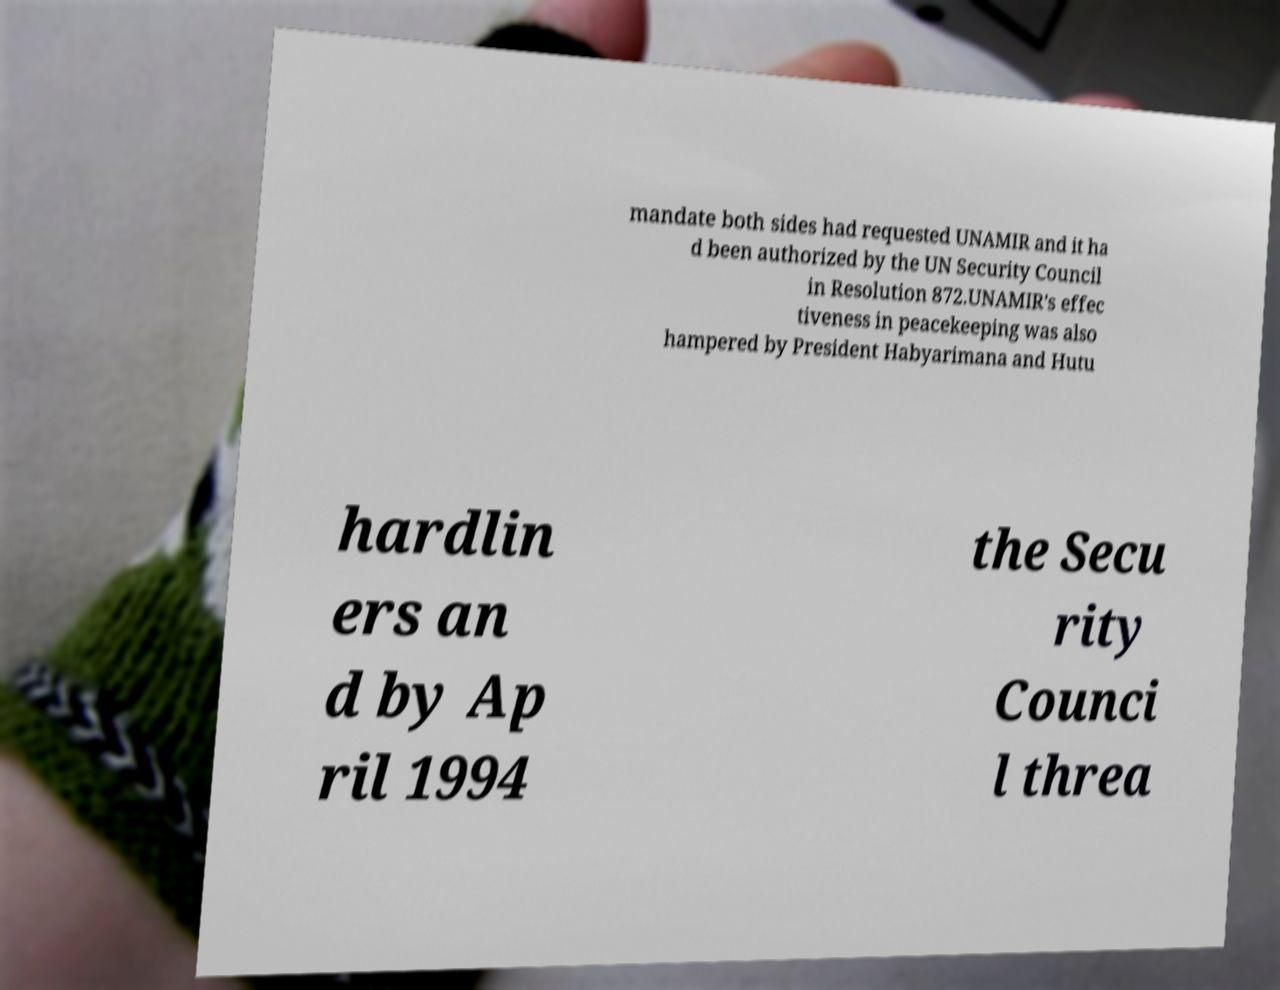Could you assist in decoding the text presented in this image and type it out clearly? mandate both sides had requested UNAMIR and it ha d been authorized by the UN Security Council in Resolution 872.UNAMIR's effec tiveness in peacekeeping was also hampered by President Habyarimana and Hutu hardlin ers an d by Ap ril 1994 the Secu rity Counci l threa 